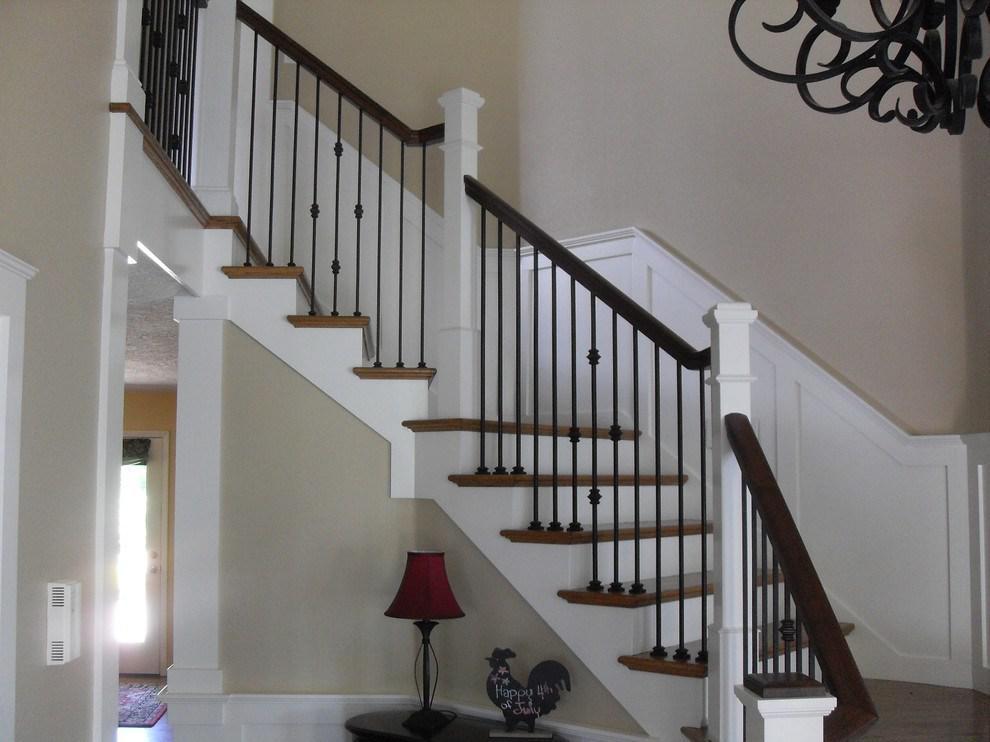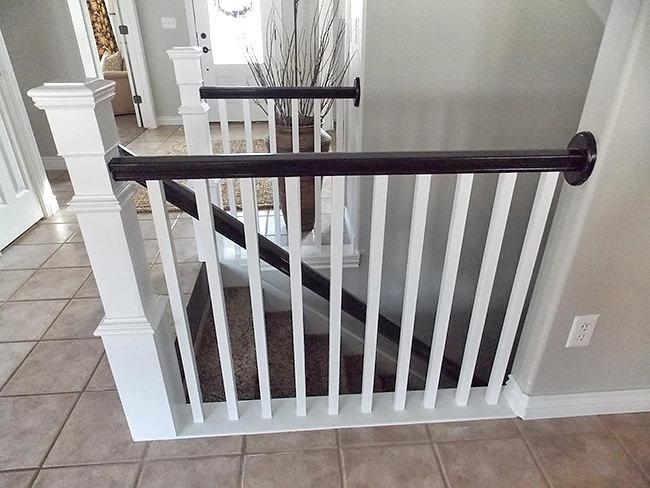The first image is the image on the left, the second image is the image on the right. Examine the images to the left and right. Is the description "Each image shows at least one square corner post and straight white bars flanking a descending flight of stairs." accurate? Answer yes or no. No. 